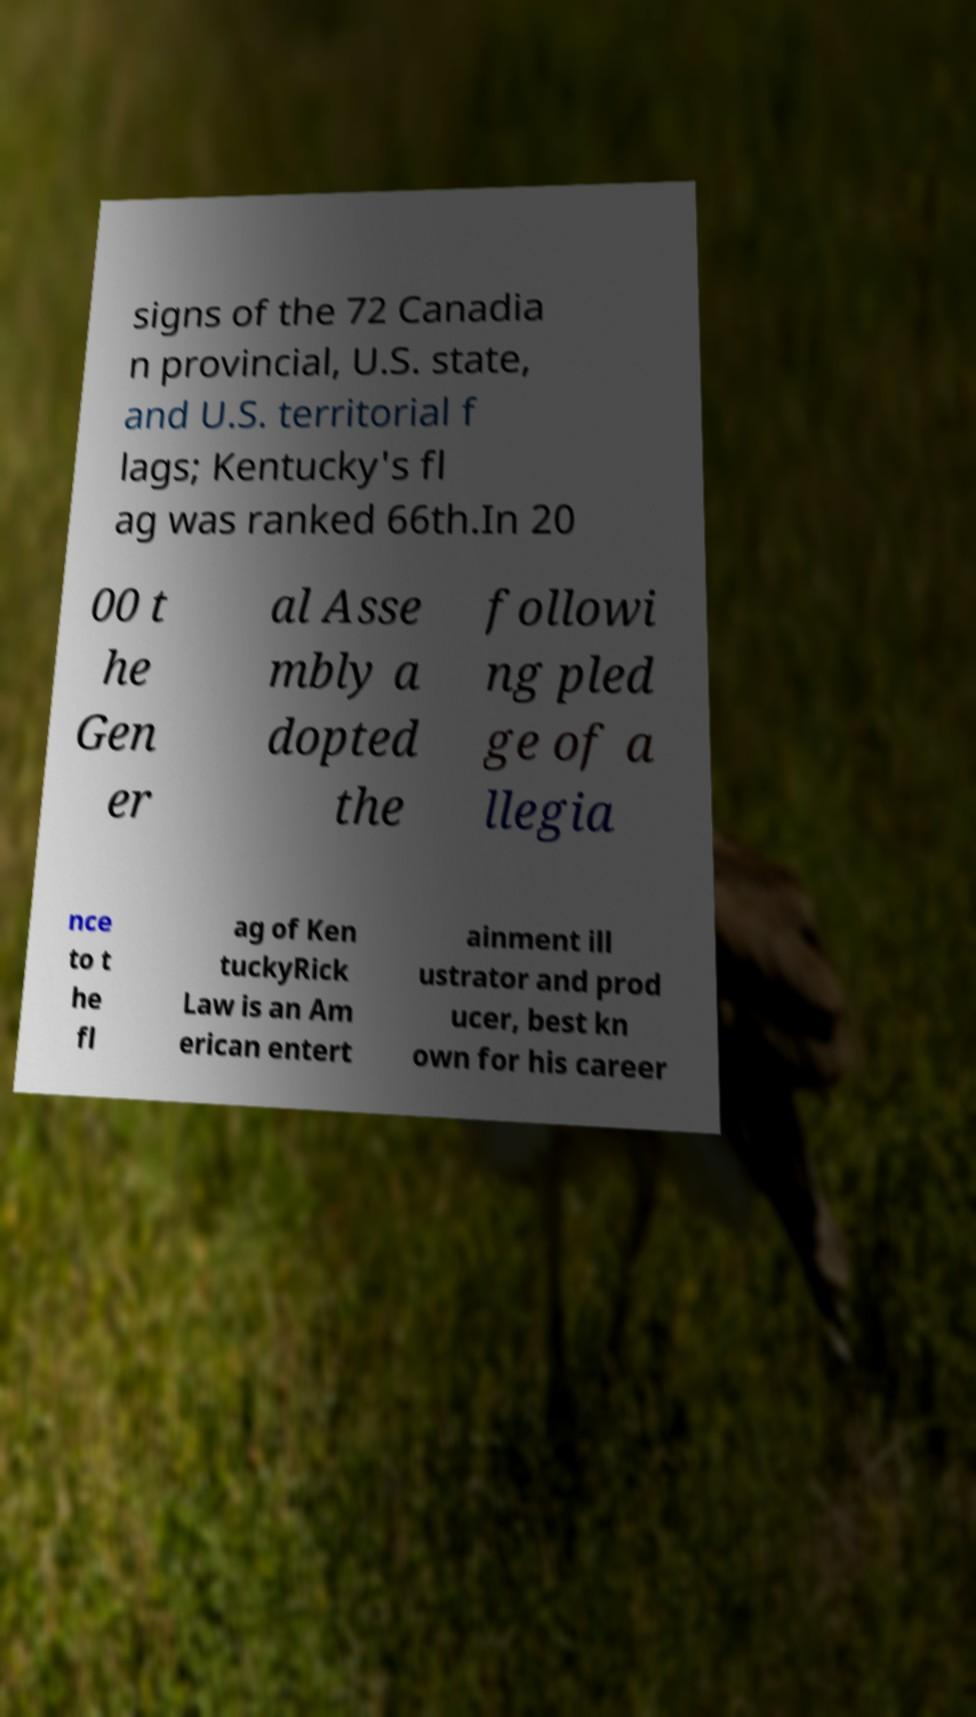Could you assist in decoding the text presented in this image and type it out clearly? signs of the 72 Canadia n provincial, U.S. state, and U.S. territorial f lags; Kentucky's fl ag was ranked 66th.In 20 00 t he Gen er al Asse mbly a dopted the followi ng pled ge of a llegia nce to t he fl ag of Ken tuckyRick Law is an Am erican entert ainment ill ustrator and prod ucer, best kn own for his career 